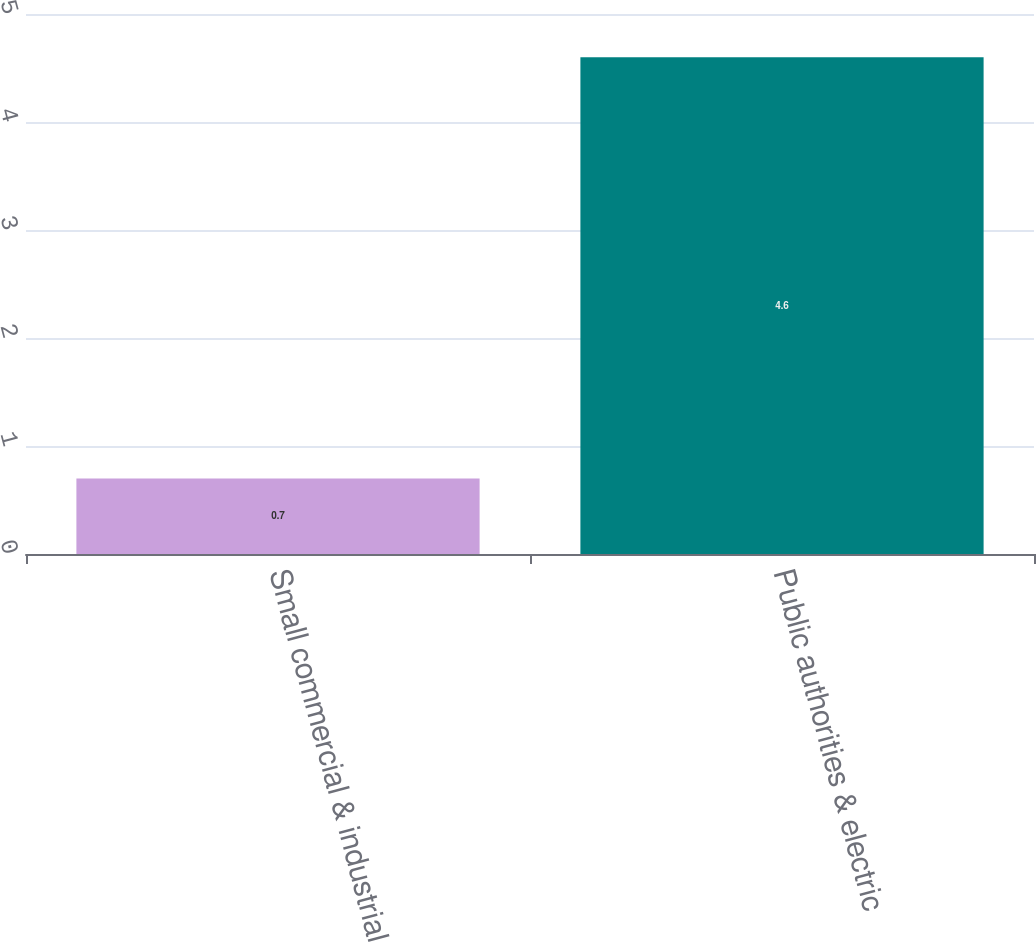Convert chart. <chart><loc_0><loc_0><loc_500><loc_500><bar_chart><fcel>Small commercial & industrial<fcel>Public authorities & electric<nl><fcel>0.7<fcel>4.6<nl></chart> 